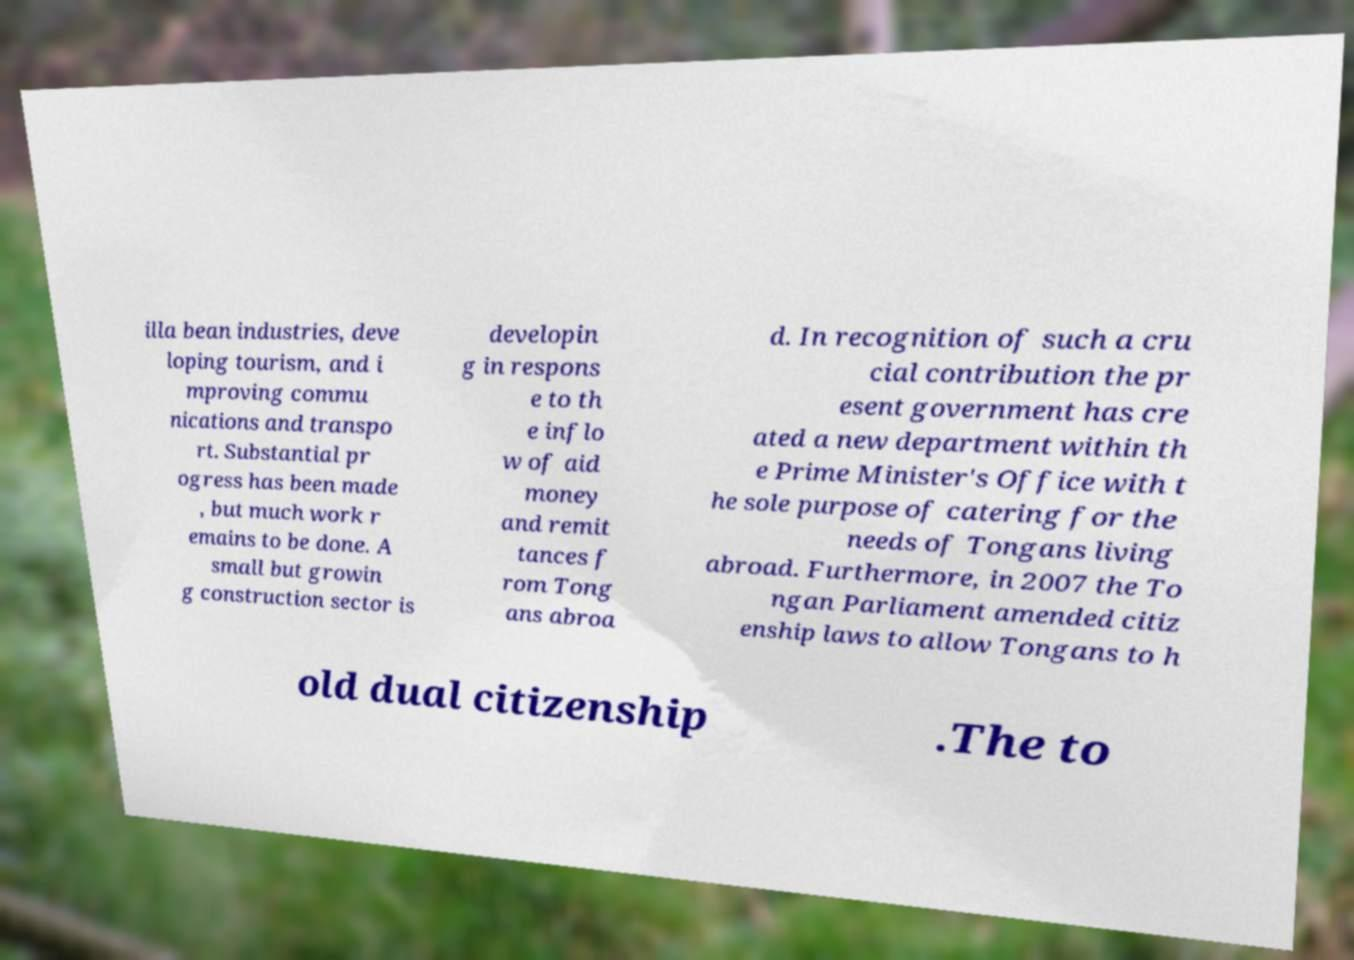Please read and relay the text visible in this image. What does it say? illa bean industries, deve loping tourism, and i mproving commu nications and transpo rt. Substantial pr ogress has been made , but much work r emains to be done. A small but growin g construction sector is developin g in respons e to th e inflo w of aid money and remit tances f rom Tong ans abroa d. In recognition of such a cru cial contribution the pr esent government has cre ated a new department within th e Prime Minister's Office with t he sole purpose of catering for the needs of Tongans living abroad. Furthermore, in 2007 the To ngan Parliament amended citiz enship laws to allow Tongans to h old dual citizenship .The to 